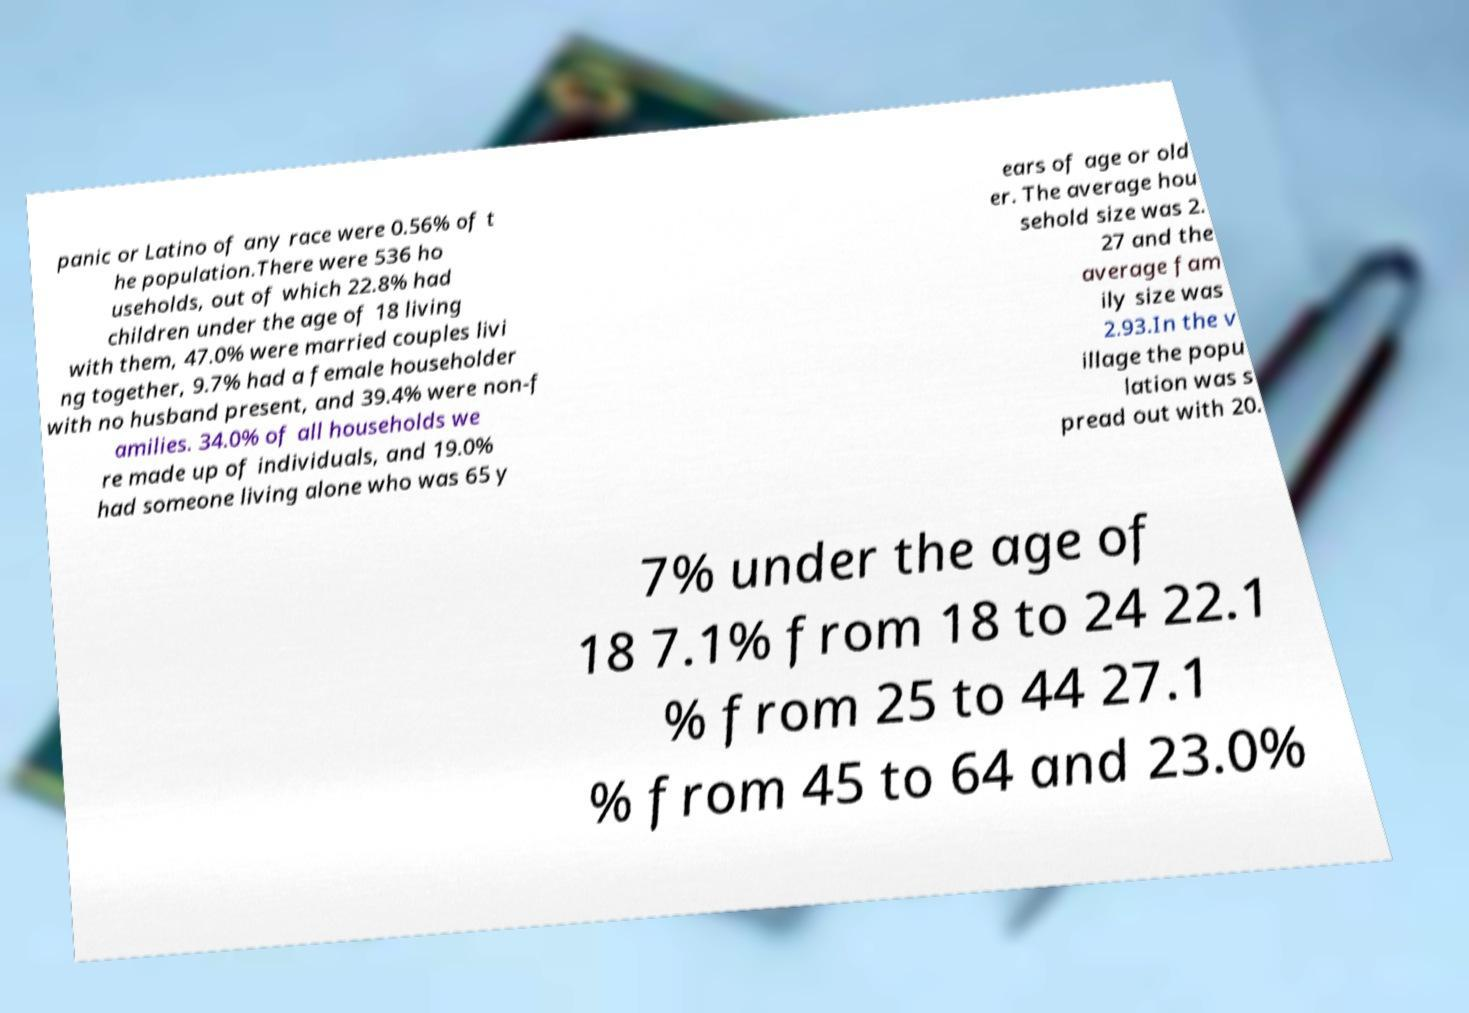For documentation purposes, I need the text within this image transcribed. Could you provide that? panic or Latino of any race were 0.56% of t he population.There were 536 ho useholds, out of which 22.8% had children under the age of 18 living with them, 47.0% were married couples livi ng together, 9.7% had a female householder with no husband present, and 39.4% were non-f amilies. 34.0% of all households we re made up of individuals, and 19.0% had someone living alone who was 65 y ears of age or old er. The average hou sehold size was 2. 27 and the average fam ily size was 2.93.In the v illage the popu lation was s pread out with 20. 7% under the age of 18 7.1% from 18 to 24 22.1 % from 25 to 44 27.1 % from 45 to 64 and 23.0% 